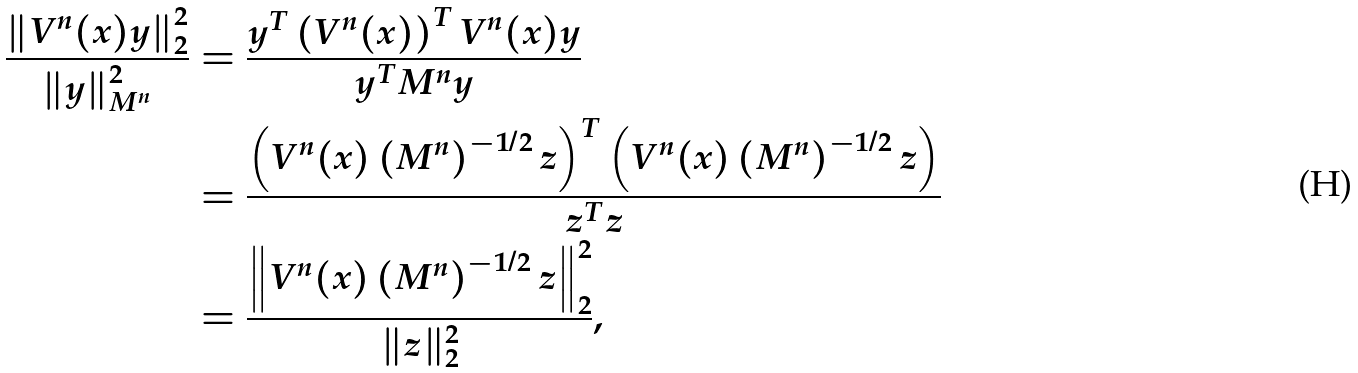<formula> <loc_0><loc_0><loc_500><loc_500>\frac { \left \| V ^ { n } ( x ) y \right \| ^ { 2 } _ { 2 } } { \left \| y \right \| ^ { 2 } _ { M ^ { n } } } & = \frac { y ^ { T } \left ( V ^ { n } ( x ) \right ) ^ { T } V ^ { n } ( x ) y } { y ^ { T } M ^ { n } y } \\ & = \frac { \left ( V ^ { n } ( x ) \left ( M ^ { n } \right ) ^ { - 1 / 2 } z \right ) ^ { T } \left ( V ^ { n } ( x ) \left ( M ^ { n } \right ) ^ { - 1 / 2 } z \right ) } { z ^ { T } z } \\ & = \frac { \left \| V ^ { n } ( x ) \left ( M ^ { n } \right ) ^ { - 1 / 2 } z \right \| ^ { 2 } _ { 2 } } { \| z \| ^ { 2 } _ { 2 } } ,</formula> 